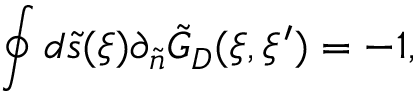<formula> <loc_0><loc_0><loc_500><loc_500>\oint { d } \tilde { s } ( \xi ) { \partial _ { \tilde { n } } } { \tilde { G } _ { D } } ( \xi , \xi ^ { \prime } ) = - 1 ,</formula> 